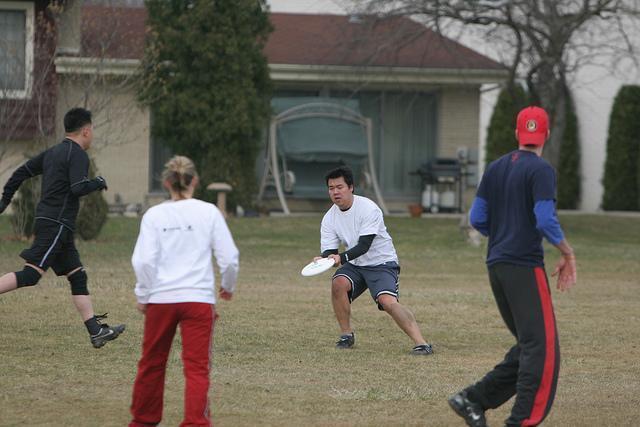How many people are in the picture?
Give a very brief answer. 4. How many sheep are there?
Give a very brief answer. 0. 